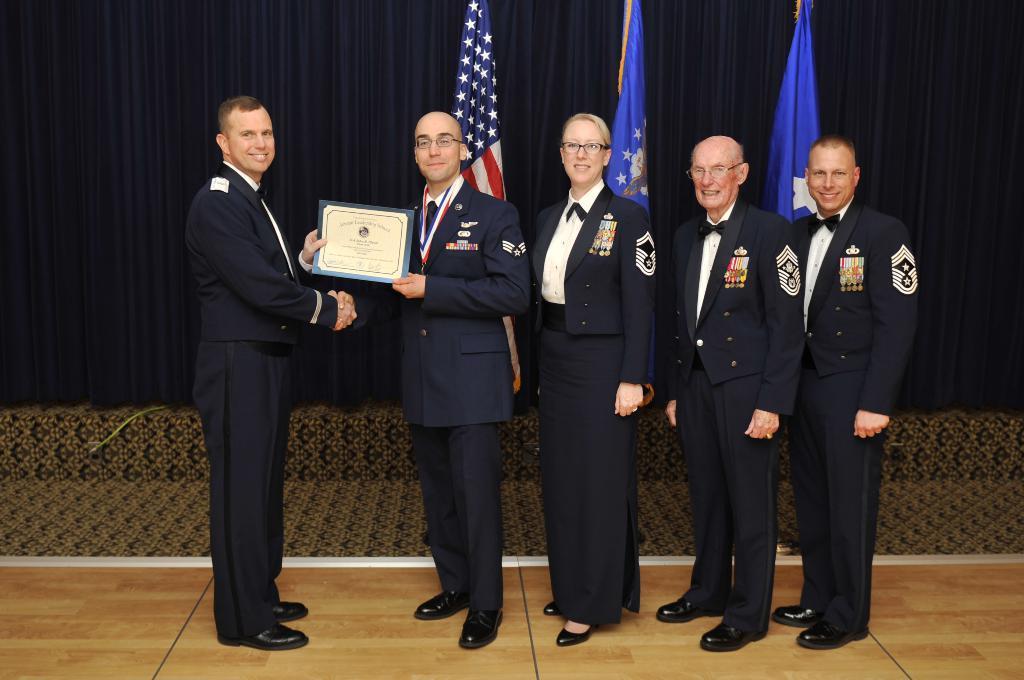Describe this image in one or two sentences. In this image there are a few people standing with a smile on their face, one of them is holding a memo and giving to the other person, behind them there are flags. 